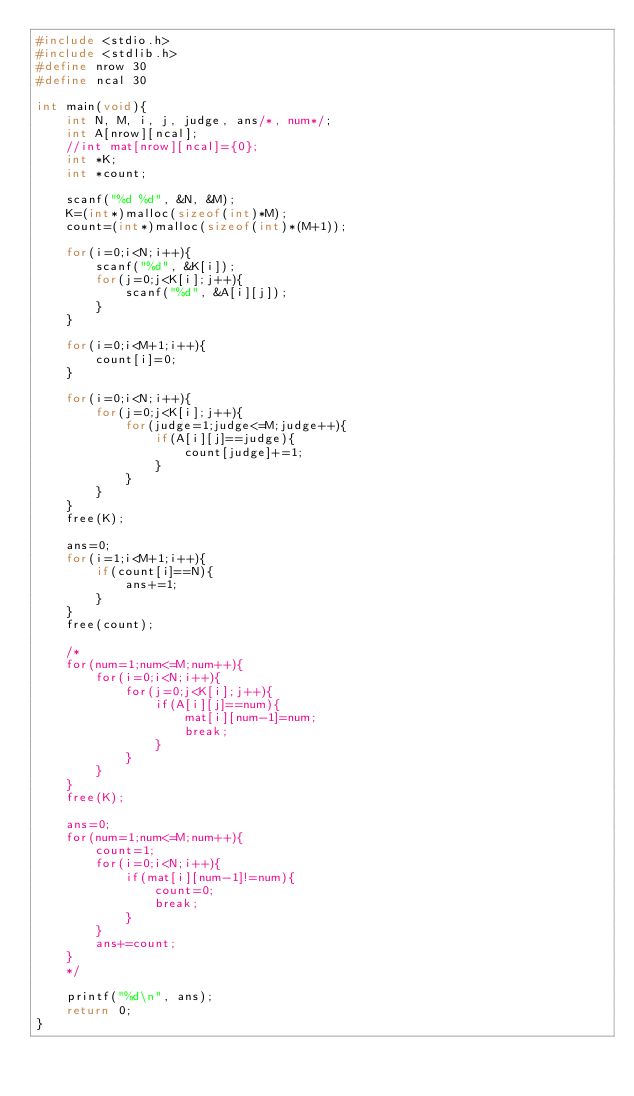<code> <loc_0><loc_0><loc_500><loc_500><_C_>#include <stdio.h>
#include <stdlib.h>
#define nrow 30
#define ncal 30

int main(void){
    int N, M, i, j, judge, ans/*, num*/;
    int A[nrow][ncal];
    //int mat[nrow][ncal]={0};
    int *K;
    int *count;

    scanf("%d %d", &N, &M);
    K=(int*)malloc(sizeof(int)*M);
    count=(int*)malloc(sizeof(int)*(M+1));

    for(i=0;i<N;i++){
        scanf("%d", &K[i]);
        for(j=0;j<K[i];j++){
            scanf("%d", &A[i][j]);
        }
    }

    for(i=0;i<M+1;i++){
        count[i]=0;
    }

    for(i=0;i<N;i++){
        for(j=0;j<K[i];j++){
            for(judge=1;judge<=M;judge++){
                if(A[i][j]==judge){
                    count[judge]+=1;
                }
            }
        }
    }
    free(K);

    ans=0;
    for(i=1;i<M+1;i++){
        if(count[i]==N){
            ans+=1;
        }
    }
    free(count);

    /*
    for(num=1;num<=M;num++){
        for(i=0;i<N;i++){
            for(j=0;j<K[i];j++){
                if(A[i][j]==num){
                    mat[i][num-1]=num;
                    break;
                }
            }
        }    
    }
    free(K);

    ans=0;
    for(num=1;num<=M;num++){
        count=1;
        for(i=0;i<N;i++){
            if(mat[i][num-1]!=num){
                count=0;
                break;
            }
        }
        ans+=count;
    }
    */
    
    printf("%d\n", ans);
    return 0;
}</code> 